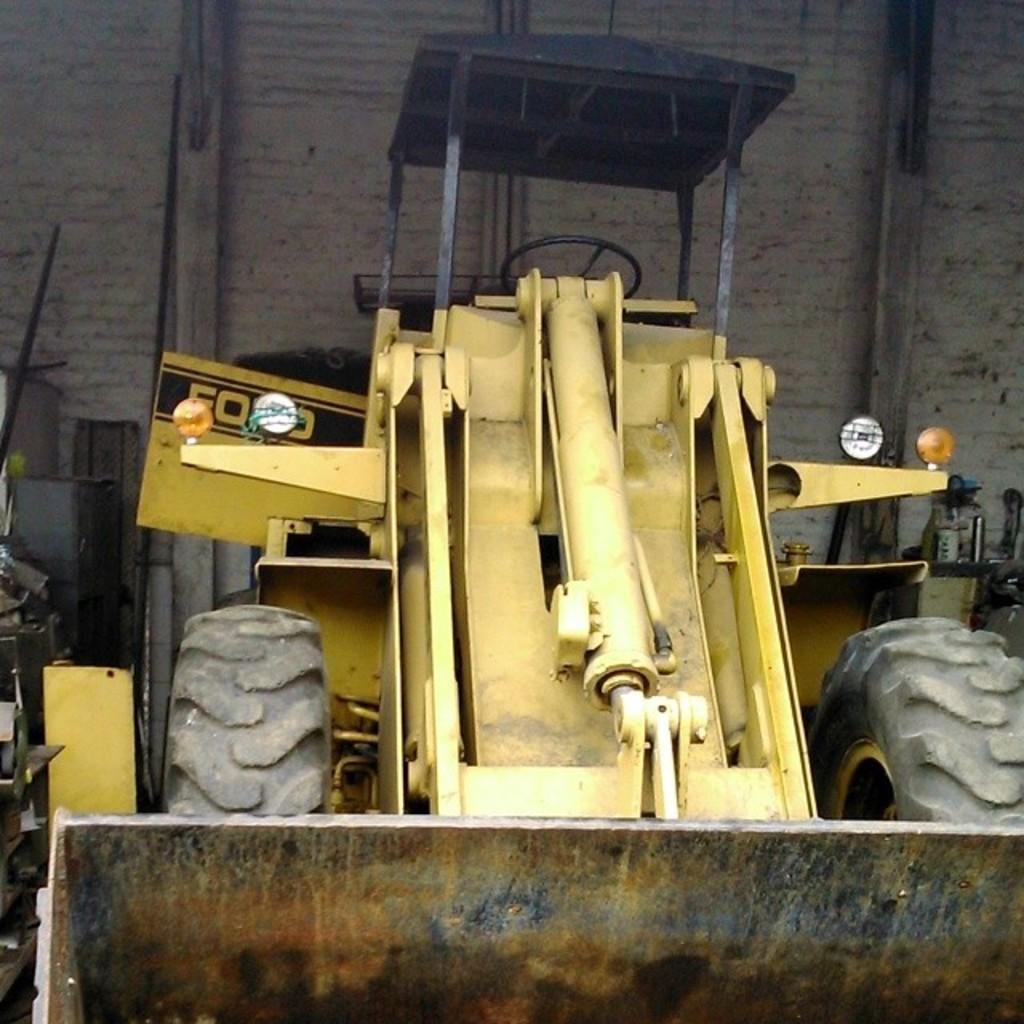Could you give a brief overview of what you see in this image? In this image there is a bulldozer on the ground. Behind it there is a wall. To the left there are a few objects on the ground. 